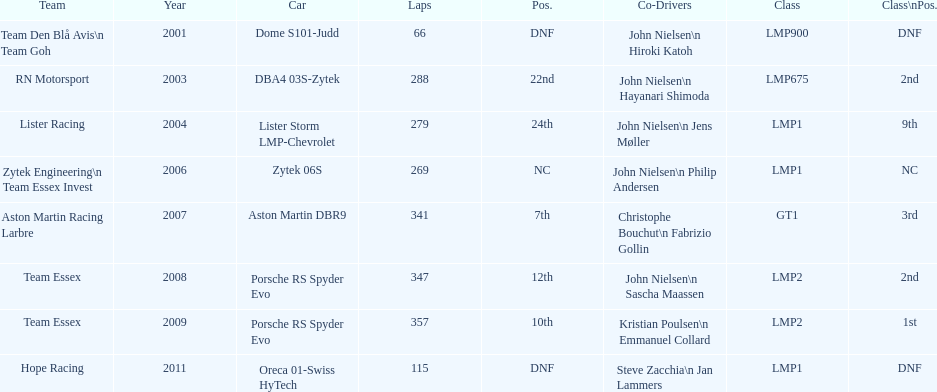How many times was the final position above 20? 2. 